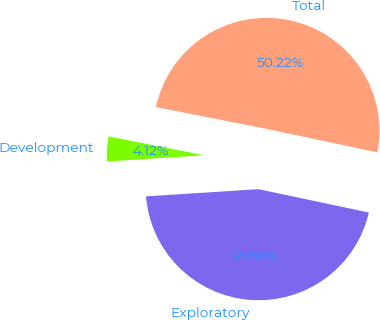Convert chart to OTSL. <chart><loc_0><loc_0><loc_500><loc_500><pie_chart><fcel>Development<fcel>Exploratory<fcel>Total<nl><fcel>4.12%<fcel>45.66%<fcel>50.22%<nl></chart> 